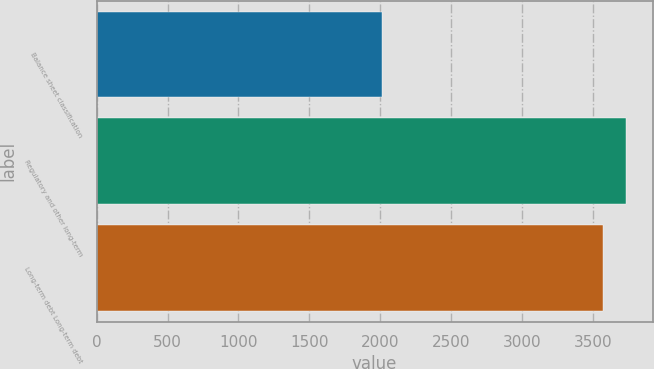<chart> <loc_0><loc_0><loc_500><loc_500><bar_chart><fcel>Balance sheet classification<fcel>Regulatory and other long-term<fcel>Long-term debt Long-term debt<nl><fcel>2014<fcel>3732.2<fcel>3570<nl></chart> 